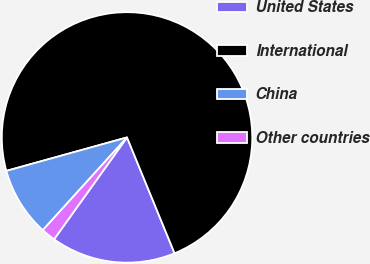<chart> <loc_0><loc_0><loc_500><loc_500><pie_chart><fcel>United States<fcel>International<fcel>China<fcel>Other countries<nl><fcel>16.09%<fcel>73.11%<fcel>8.96%<fcel>1.84%<nl></chart> 